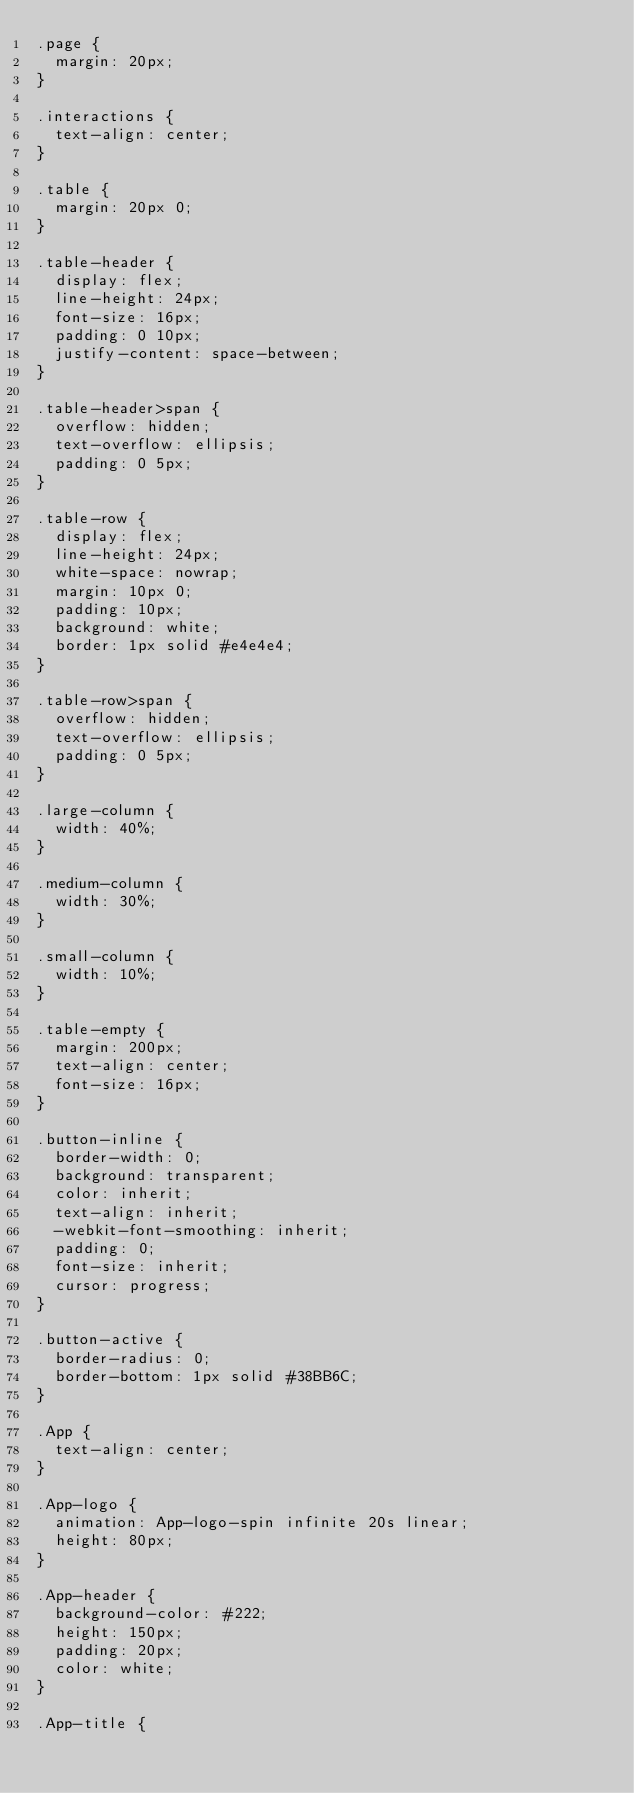<code> <loc_0><loc_0><loc_500><loc_500><_CSS_>.page {
  margin: 20px;
}

.interactions {
  text-align: center;
}

.table {
  margin: 20px 0;
}

.table-header {
  display: flex;
  line-height: 24px;
  font-size: 16px;
  padding: 0 10px;
  justify-content: space-between;
}

.table-header>span {
  overflow: hidden;
  text-overflow: ellipsis;
  padding: 0 5px;
}

.table-row {
  display: flex;
  line-height: 24px;
  white-space: nowrap;
  margin: 10px 0;
  padding: 10px;
  background: white;
  border: 1px solid #e4e4e4;
}

.table-row>span {
  overflow: hidden;
  text-overflow: ellipsis;
  padding: 0 5px;
}

.large-column {
  width: 40%;
}

.medium-column {
  width: 30%;
}

.small-column {
  width: 10%;
}

.table-empty {
  margin: 200px;
  text-align: center;
  font-size: 16px;
}

.button-inline {
  border-width: 0;
  background: transparent;
  color: inherit;
  text-align: inherit;
  -webkit-font-smoothing: inherit;
  padding: 0;
  font-size: inherit;
  cursor: progress;
}

.button-active {
  border-radius: 0;
  border-bottom: 1px solid #38BB6C;
}

.App {
  text-align: center;
}

.App-logo {
  animation: App-logo-spin infinite 20s linear;
  height: 80px;
}

.App-header {
  background-color: #222;
  height: 150px;
  padding: 20px;
  color: white;
}

.App-title {</code> 